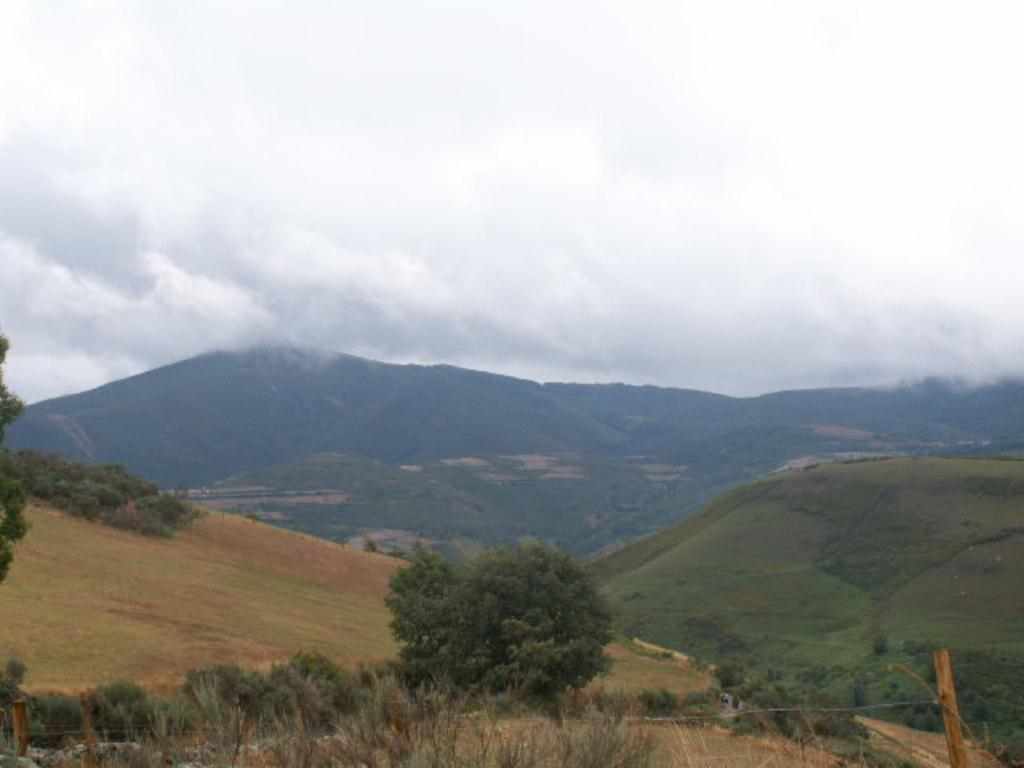What type of landscape can be seen in the background of the image? There are hills in the background of the image. What can be found on the hills? The hills have trees on them. What is visible in the sky in the image? The sky is visible in the image. What can be observed in the sky? Clouds are present in the sky. What type of dental treatment is being performed on the trees in the image? There is no dental treatment being performed on the trees in the image; the trees are simply present on the hills. 